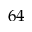Convert formula to latex. <formula><loc_0><loc_0><loc_500><loc_500>6 4</formula> 